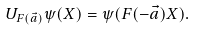Convert formula to latex. <formula><loc_0><loc_0><loc_500><loc_500>U _ { F ( \vec { a } ) } \psi ( X ) = \psi ( F ( - \vec { a } ) X ) .</formula> 